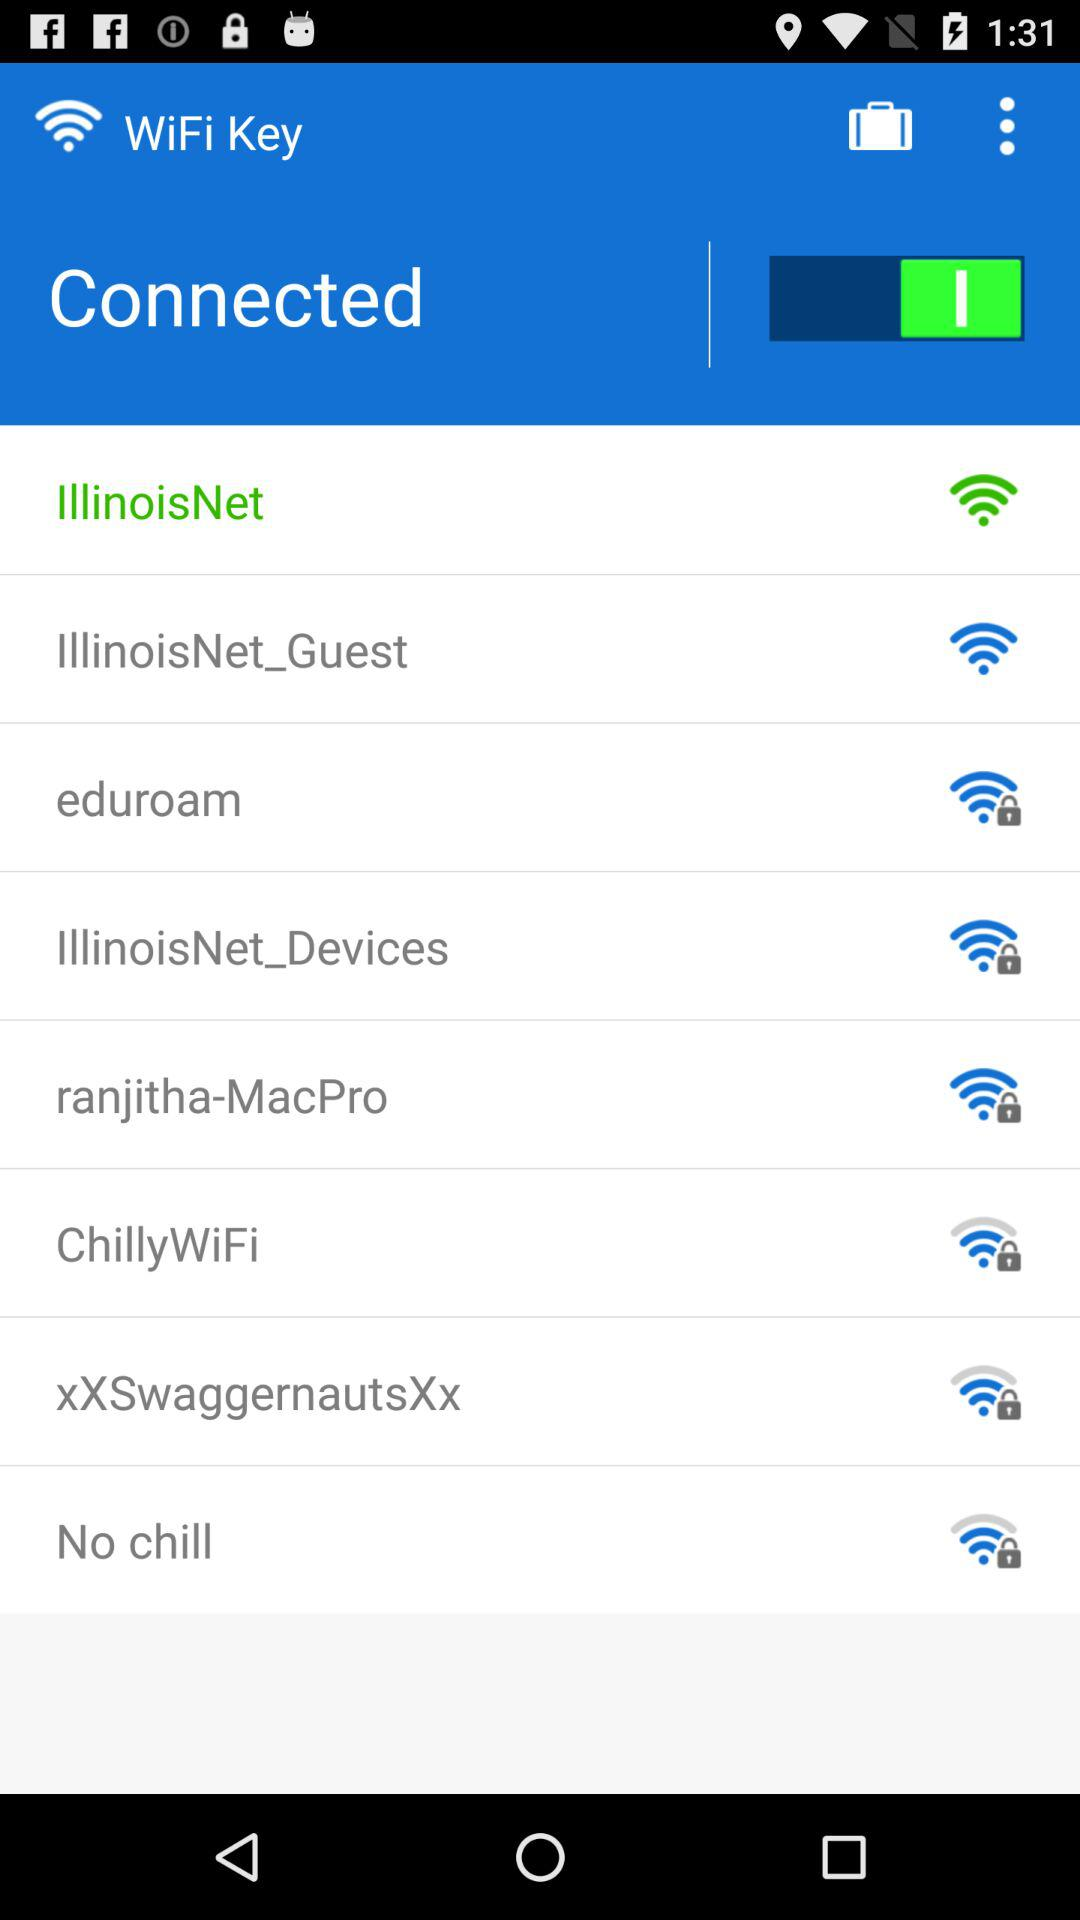How many networks are not connected?
Answer the question using a single word or phrase. 7 